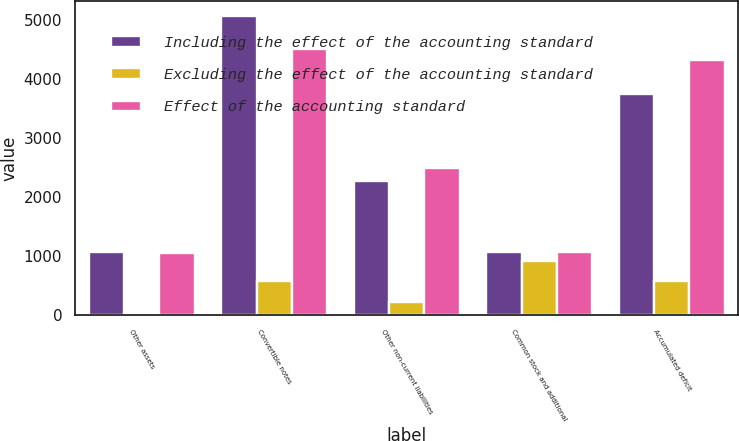Convert chart to OTSL. <chart><loc_0><loc_0><loc_500><loc_500><stacked_bar_chart><ecel><fcel>Other assets<fcel>Convertible notes<fcel>Other non-current liabilities<fcel>Common stock and additional<fcel>Accumulated deficit<nl><fcel>Including the effect of the accounting standard<fcel>1069<fcel>5082<fcel>2274<fcel>1069<fcel>3752<nl><fcel>Excluding the effect of the accounting standard<fcel>12<fcel>570<fcel>214<fcel>914<fcel>570<nl><fcel>Effect of the accounting standard<fcel>1057<fcel>4512<fcel>2488<fcel>1069<fcel>4322<nl></chart> 